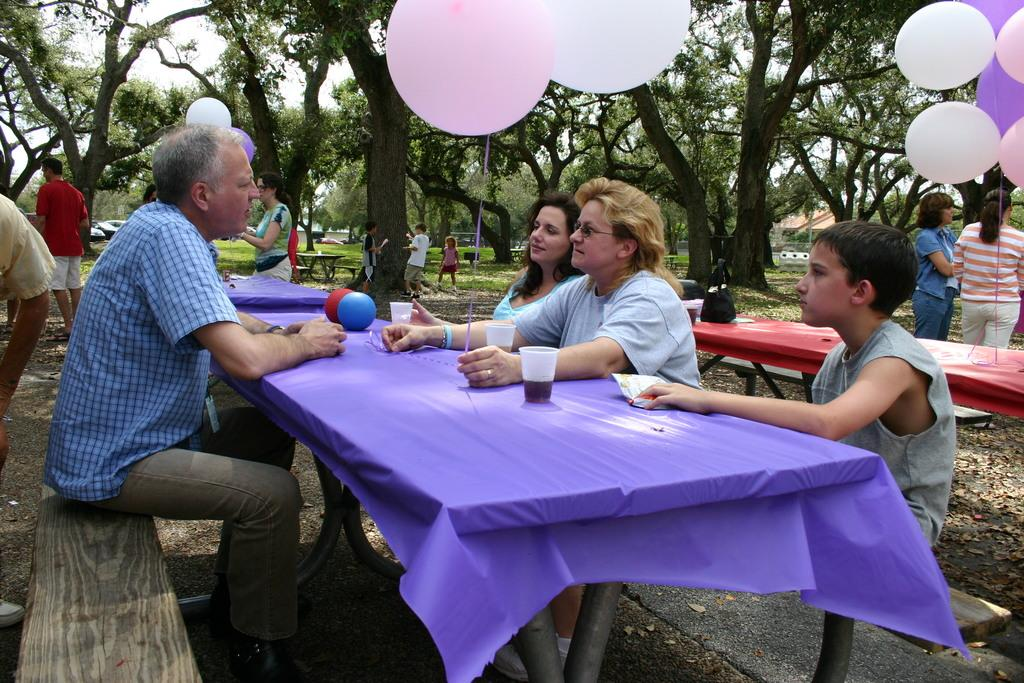How many people are in the image? There is a group of people in the image. What are the people doing in the image? The people are sitting on a bench. What is in front of the bench? There is a table in front of the bench. What can be seen in the background of the image? There are trees visible in the image. What decorative items are present in the image? There are balloons in the image. What type of knee surgery is being performed on the person in the image? There is no person undergoing knee surgery in the image; it features a group of people sitting on a bench. 